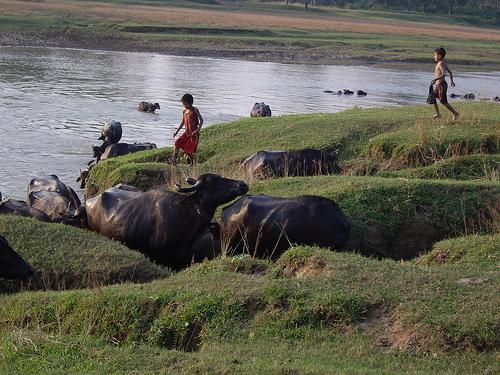What is the primary focus of the image and how is it interacting with its environment? The primary focus is a group of hippos on the ground, resting in a grassy area near water where boys and cows are also present. Convey the essence of the image in a single sentence. In a serene riverside scene, hippos rest on the ground while children and cows play nearby. Highlight the central action or subject in the image and provide a brief description. The central subject is a group of hippos resting on the ground, surrounded by a grassy landscape and playful children and cows. Mention a few important components of the image and their interactions. Hippos resting on the ground, boys playing in the grass, cows in the water, and a scenic background with hills and riverbanks. List some of the subjects appearing in the image and describe the setting. Subjects: hippos, boys, cows, and grass. Setting: grassy hillside near water with animals and children interacting. Describe the overall scene captured in the image. The image shows several resting hippos, boys playing nearby, cows in the water, and a peaceful grassy hillside. What elements in the image capture the viewer's attention and what are their characteristics? The resting hippos, children playing, and cows in the water command attention with their lively interaction in a calm, grassy setting. Provide a brief summary of the most prominent element in the image and its surroundings. Hippos on the ground surrounded by grass, water, and boys playing nearby. Provide a general description of the image's content. The image features various animals and children in a picturesque landscape, with a river, hillsides, and tall grasses. Briefly describe the main subjects and the environment depicted in the image. The image shows hippos, boys, and cows amidst a natural, grassy area with hills and water. 